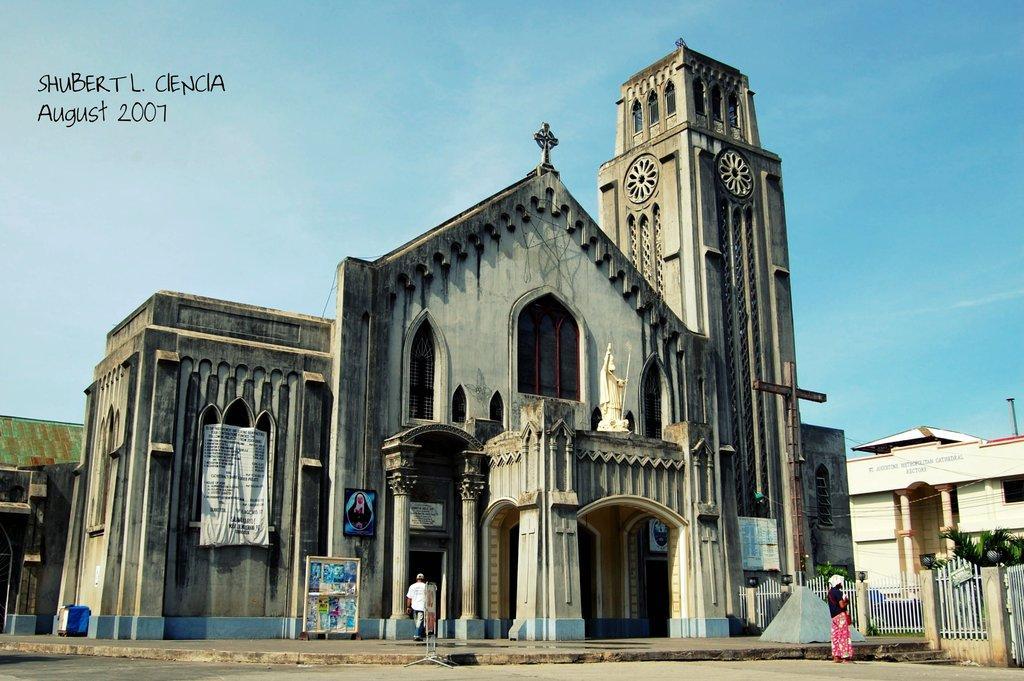In one or two sentences, can you explain what this image depicts? At the bottom of the image there is a road. And there are two persons in the image. And also there is a stand with a board. There is a building with walls, pillars, glass windows, arches, banners and frames. And also there is a statue of a person. On the right side of the image there are pillars and fencing. Behind them there are trees. At the top of the image there is sky. 